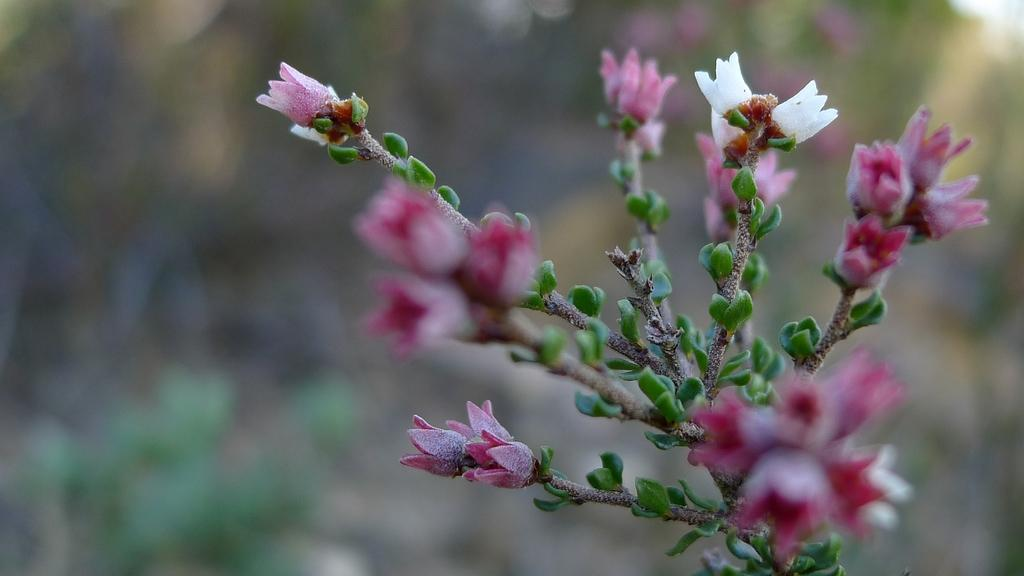What type of plant is visible in the image? There is a plant in the image, and it has flowers and leaves. Can you describe the plant's features in more detail? The plant has flowers and leaves, which are the main visible features. What can be observed about the background of the image? The background of the image is blurry. How many fingers can be seen pointing at the plant in the image? There are no fingers visible in the image, as it only features a plant with flowers and leaves against a blurry background. 